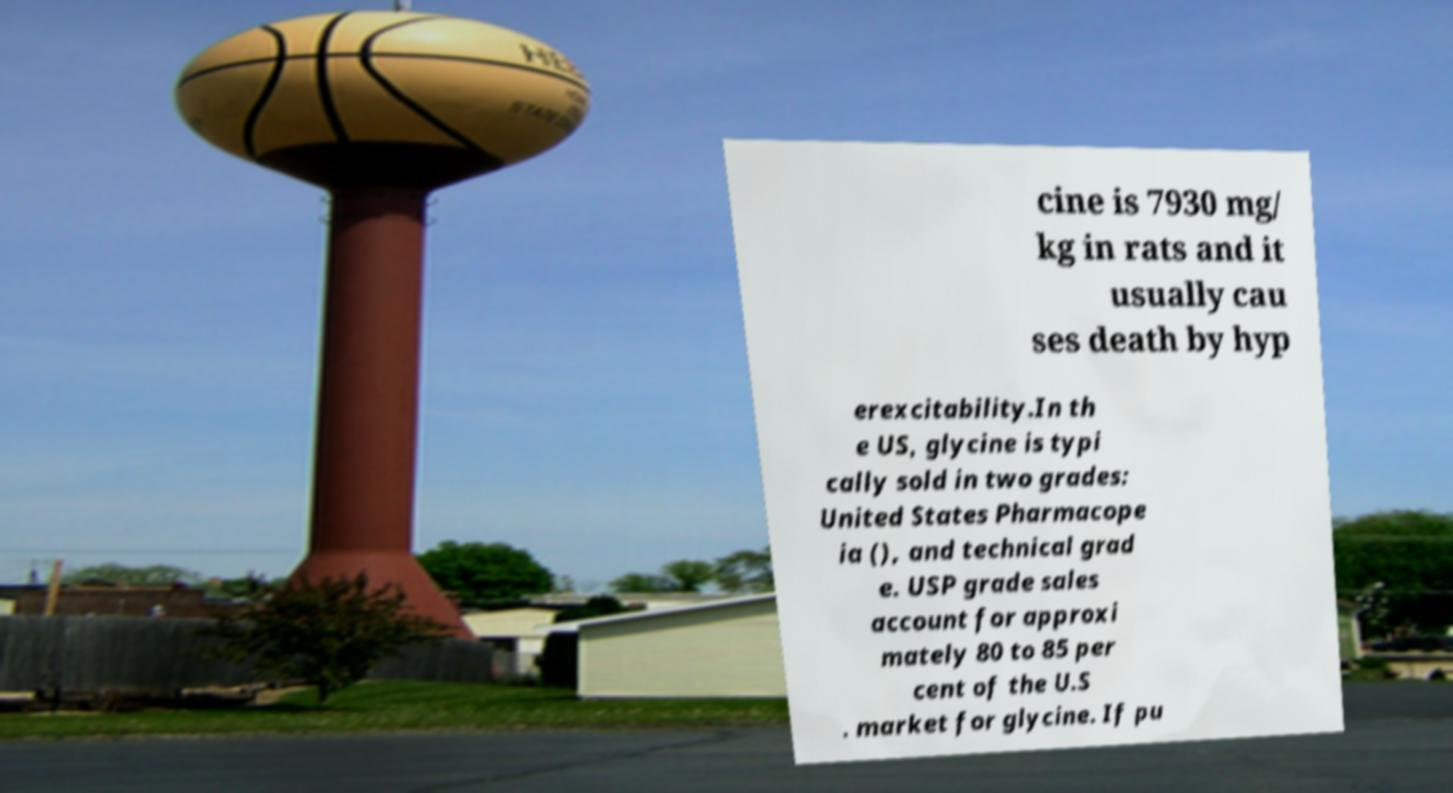There's text embedded in this image that I need extracted. Can you transcribe it verbatim? cine is 7930 mg/ kg in rats and it usually cau ses death by hyp erexcitability.In th e US, glycine is typi cally sold in two grades: United States Pharmacope ia (), and technical grad e. USP grade sales account for approxi mately 80 to 85 per cent of the U.S . market for glycine. If pu 